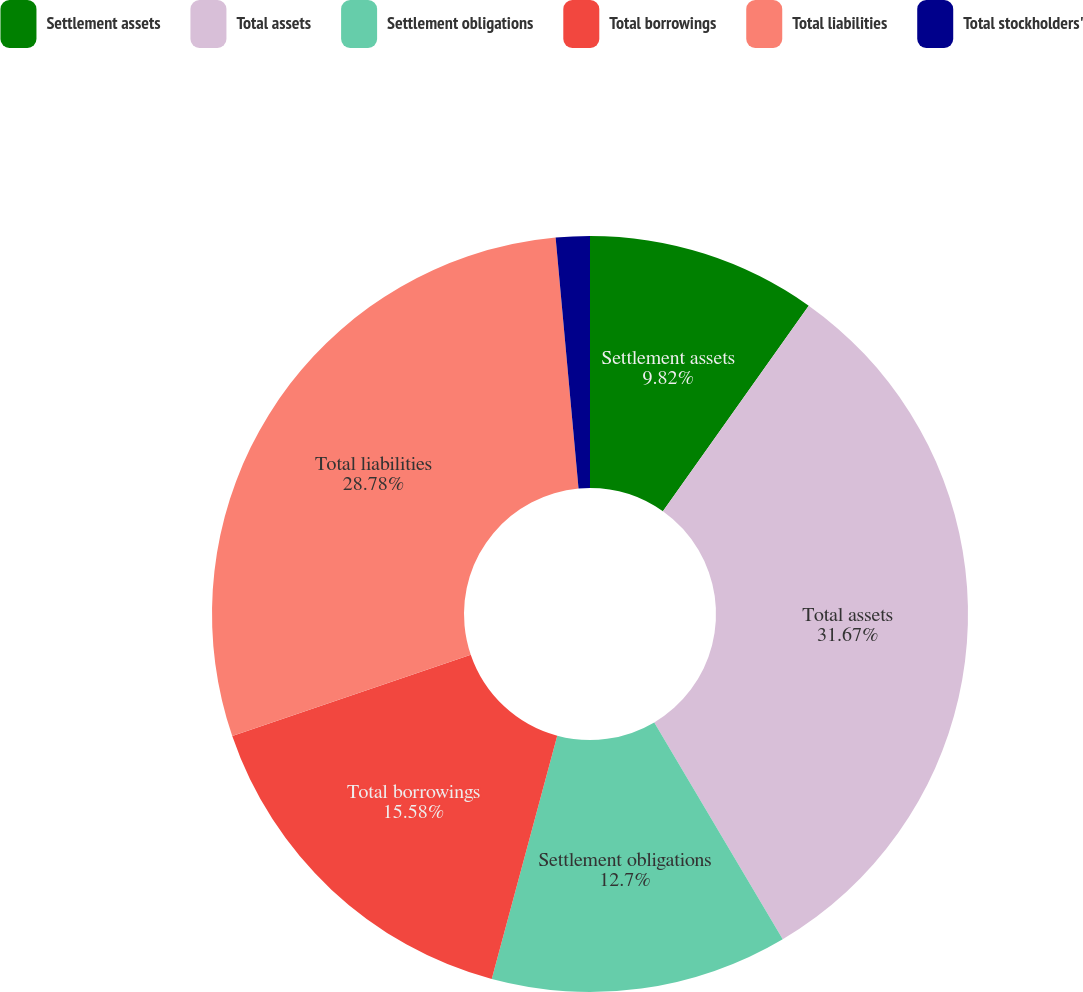Convert chart to OTSL. <chart><loc_0><loc_0><loc_500><loc_500><pie_chart><fcel>Settlement assets<fcel>Total assets<fcel>Settlement obligations<fcel>Total borrowings<fcel>Total liabilities<fcel>Total stockholders'<nl><fcel>9.82%<fcel>31.66%<fcel>12.7%<fcel>15.58%<fcel>28.78%<fcel>1.45%<nl></chart> 